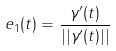Convert formula to latex. <formula><loc_0><loc_0><loc_500><loc_500>e _ { 1 } ( t ) = \frac { \gamma ^ { \prime } ( t ) } { | | \gamma ^ { \prime } ( t ) | | }</formula> 